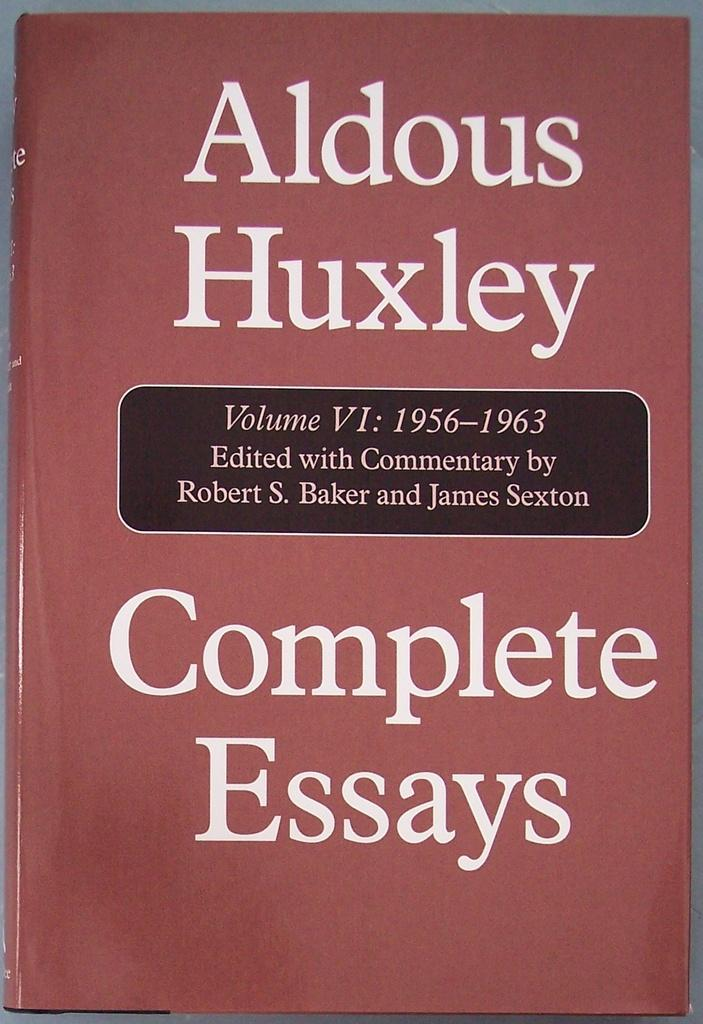Provide a one-sentence caption for the provided image. A book with a rose color contains essays by Aldous Huxley. 